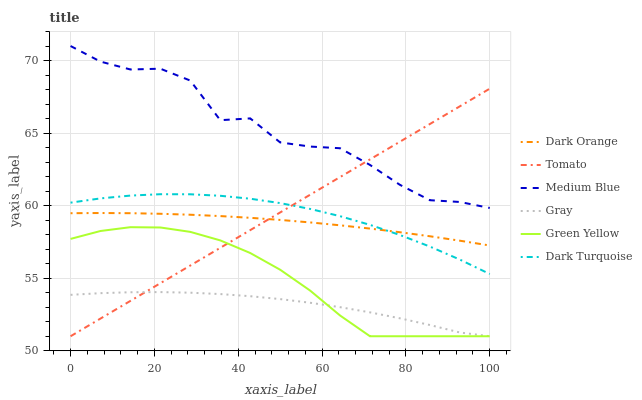Does Gray have the minimum area under the curve?
Answer yes or no. Yes. Does Medium Blue have the maximum area under the curve?
Answer yes or no. Yes. Does Dark Orange have the minimum area under the curve?
Answer yes or no. No. Does Dark Orange have the maximum area under the curve?
Answer yes or no. No. Is Tomato the smoothest?
Answer yes or no. Yes. Is Medium Blue the roughest?
Answer yes or no. Yes. Is Dark Orange the smoothest?
Answer yes or no. No. Is Dark Orange the roughest?
Answer yes or no. No. Does Tomato have the lowest value?
Answer yes or no. Yes. Does Dark Orange have the lowest value?
Answer yes or no. No. Does Medium Blue have the highest value?
Answer yes or no. Yes. Does Dark Orange have the highest value?
Answer yes or no. No. Is Gray less than Dark Turquoise?
Answer yes or no. Yes. Is Dark Turquoise greater than Green Yellow?
Answer yes or no. Yes. Does Tomato intersect Dark Orange?
Answer yes or no. Yes. Is Tomato less than Dark Orange?
Answer yes or no. No. Is Tomato greater than Dark Orange?
Answer yes or no. No. Does Gray intersect Dark Turquoise?
Answer yes or no. No. 